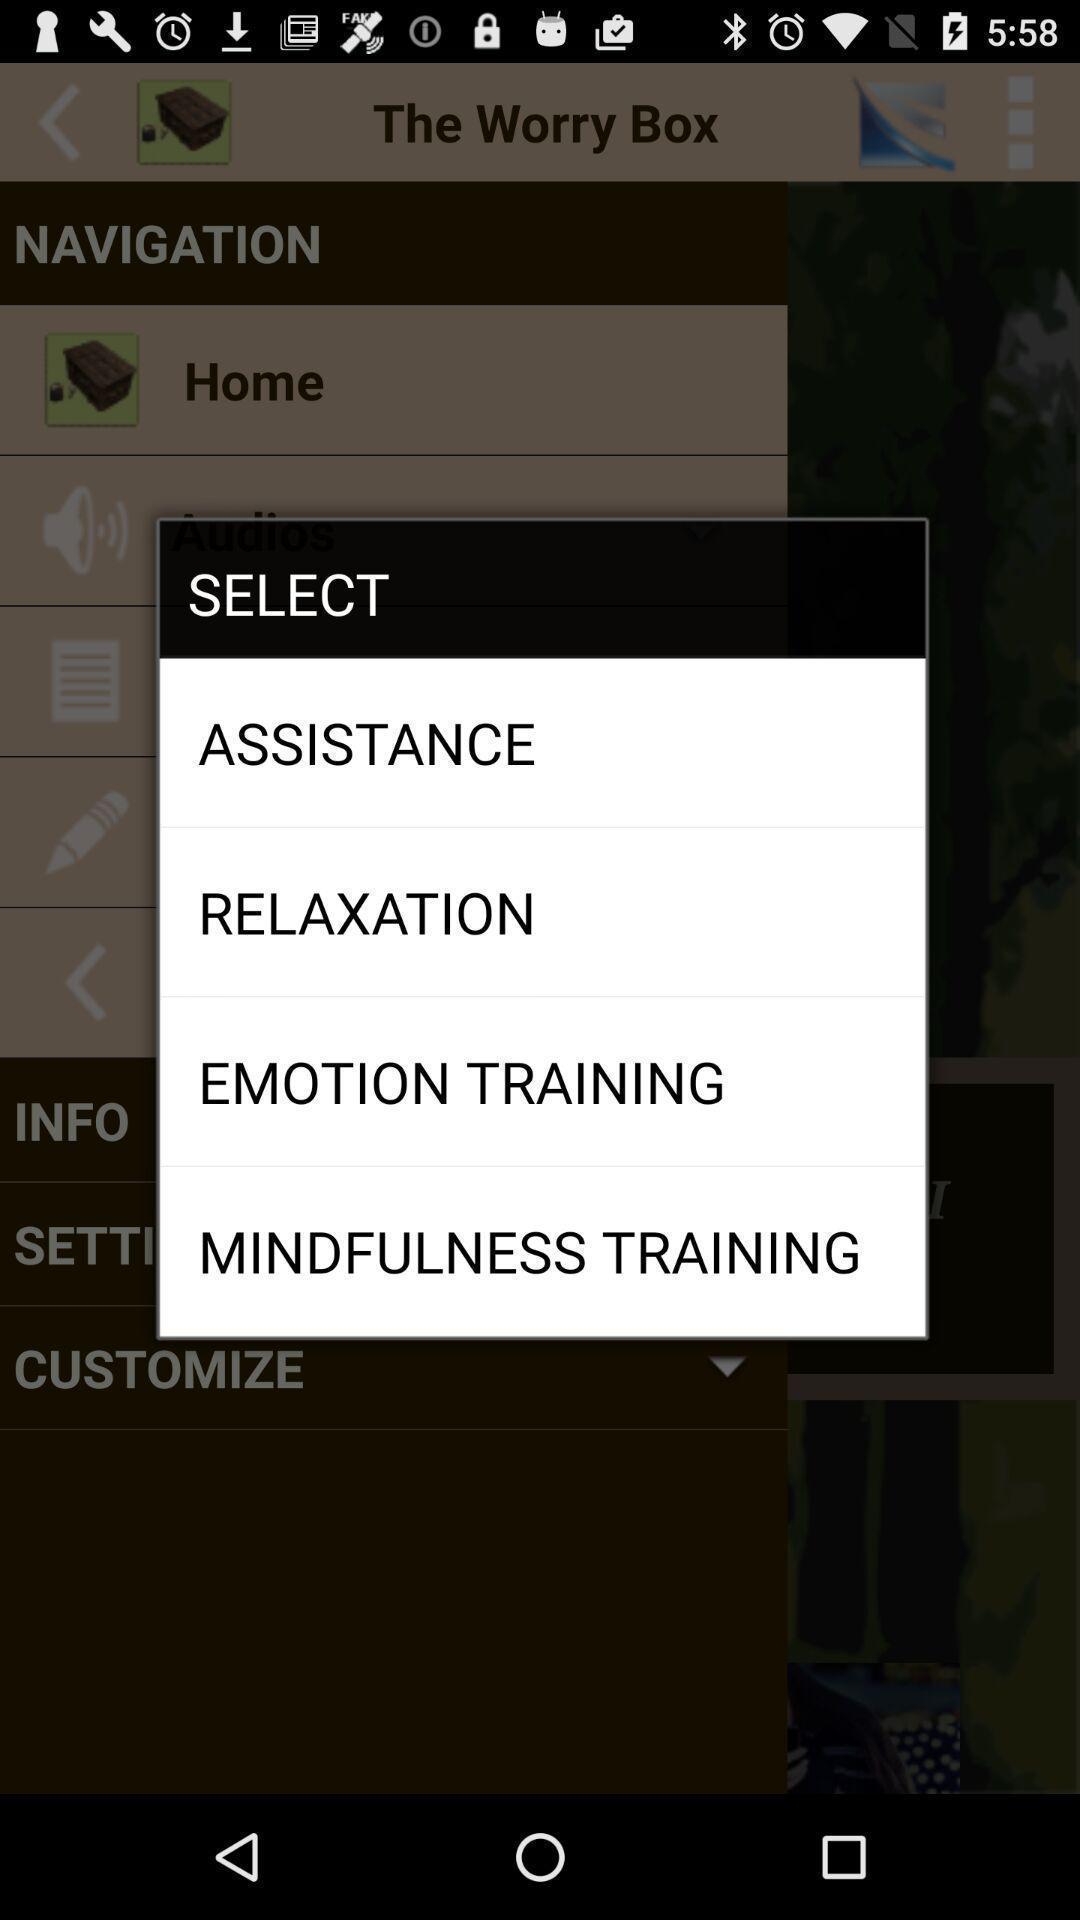Tell me about the visual elements in this screen capture. Screen displaying list of options to select. 